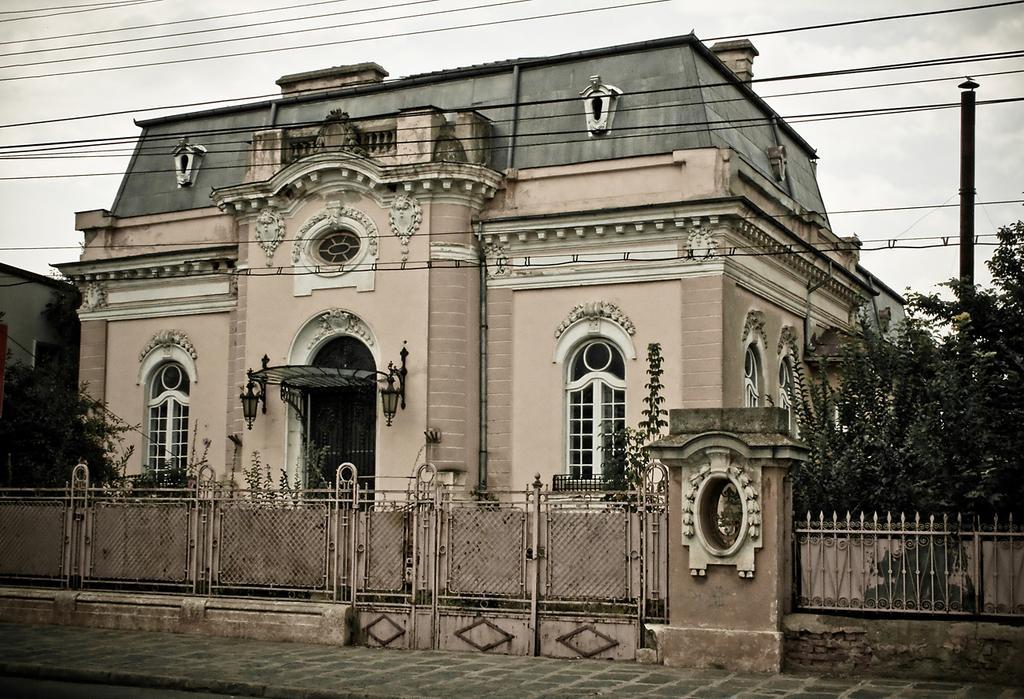In one or two sentences, can you explain what this image depicts? In this image I can see a building, a fence, a pole, trees and wires. In the background I can see the sky. 